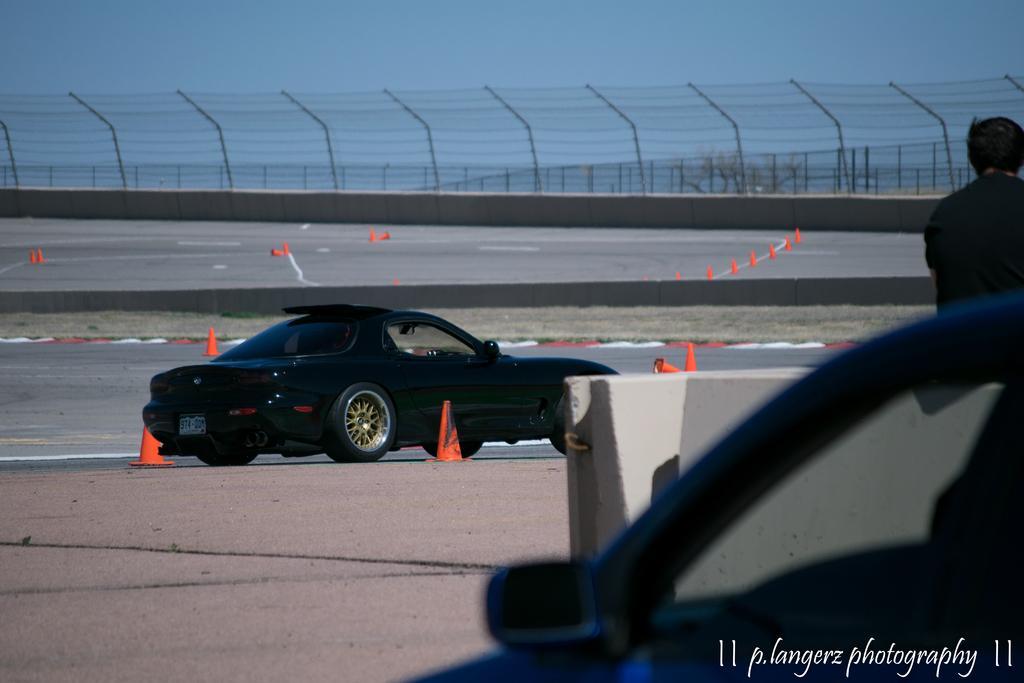Can you describe this image briefly? On the right side of the image we can see one person, one vehicle and one solid structure. At the bottom right side of the image, we can see some text. In the center of the image we can see one black car on the road. In the background we can see the sky, fences, traffic poles and a few other objects. 